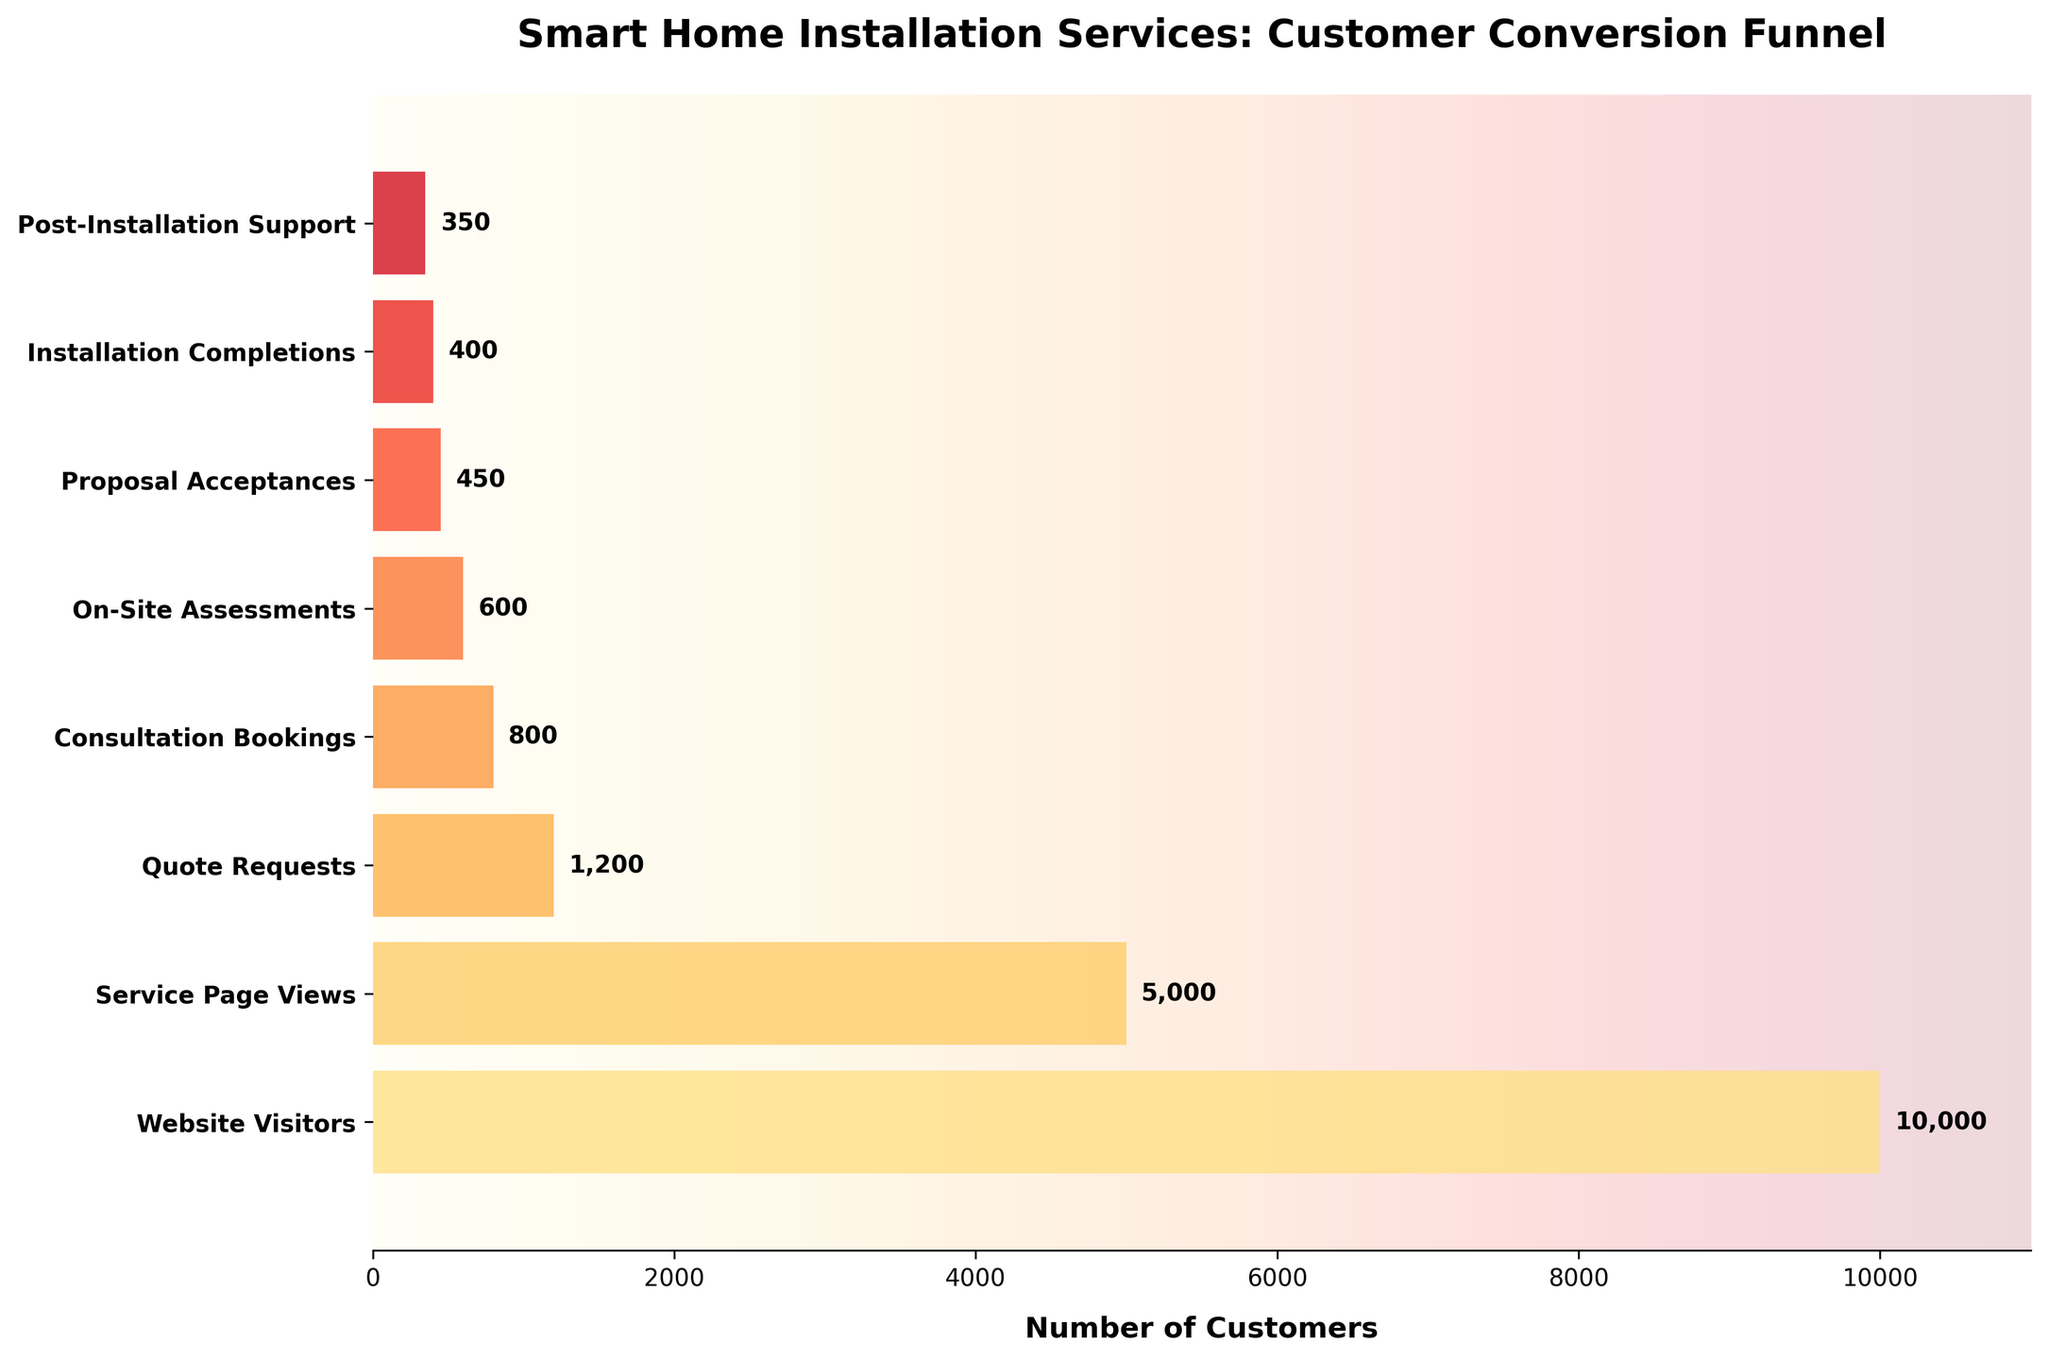what is the title of the chart? The title is the large, bold text at the top of the chart. It summarizes what the chart is about. By looking at the top of the chart, we see that the title is "Smart Home Installation Services: Customer Conversion Funnel".
Answer: Smart Home Installation Services: Customer Conversion Funnel How many stages are in the funnel? To determine the number of stages in the funnel, we can count the distinct labels on the y-axis of the chart. By counting, we see that there are 8 stages in the funnel.
Answer: 8 Which stage has the highest number of customers? To identify the stage with the highest number of customers, we look for the longest bar on the horizontal axis. The longest bar corresponds to the "Website Visitors" stage, which has 10,000 customers.
Answer: Website Visitors How many customers requested a quote? To find the number of customers who requested a quote, locate the "Quote Requests" stage on the y-axis and look at the length of its bar. The bar label indicates there are 1,200 customers.
Answer: 1200 What's the difference in the number of customers between Consultation Bookings and On-Site Assessments? To find the difference, we look at the number of customers for both stages: Consultation Bookings has 800 and On-Site Assessments has 600. We subtract 600 from 800 to find the difference.
Answer: 200 What's the conversion rate from Service Page Views to Quote Requests? We calculate the conversion rate by dividing the number of Quote Requests (1,200) by the number of Service Page Views (5,000) and multiplying by 100 for the percentage. (1,200 / 5,000) * 100 = 24%
Answer: 24% How many more customers booked consultations than requested quotes? To find this, we compare the number of customers in the "Consultation Bookings" stage (800) to those in the "Quote Requests" stage (1,200). Subtract 800 from 1,200 to find the difference.
Answer: 400 fewer What percentage of Website Visitors ended up completing the installation? We calculate the percentage by dividing the number of Installation Completions (400) by the number of Website Visitors (10,000) and multiplying by 100. (400 / 10,000) * 100 = 4%
Answer: 4% Which stage has the smallest decrease in customer numbers compared to the previous stage? We need to find the stage with the smallest drop compared to its preceding stage. By analyzing each transition, we see that the smallest decrease is from On-Site Assessments (600) to Proposal Acceptances (450), with a decrease of 150 customers.
Answer: Between On-Site Assessments and Proposal Acceptances 